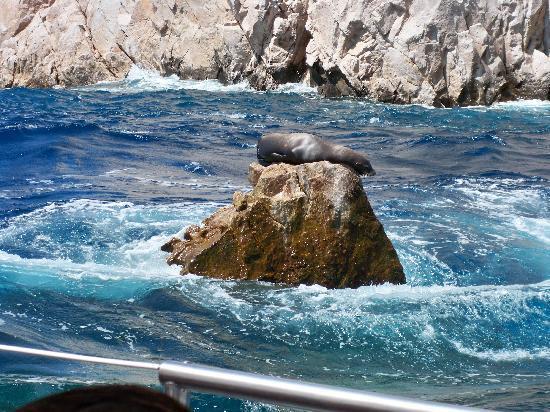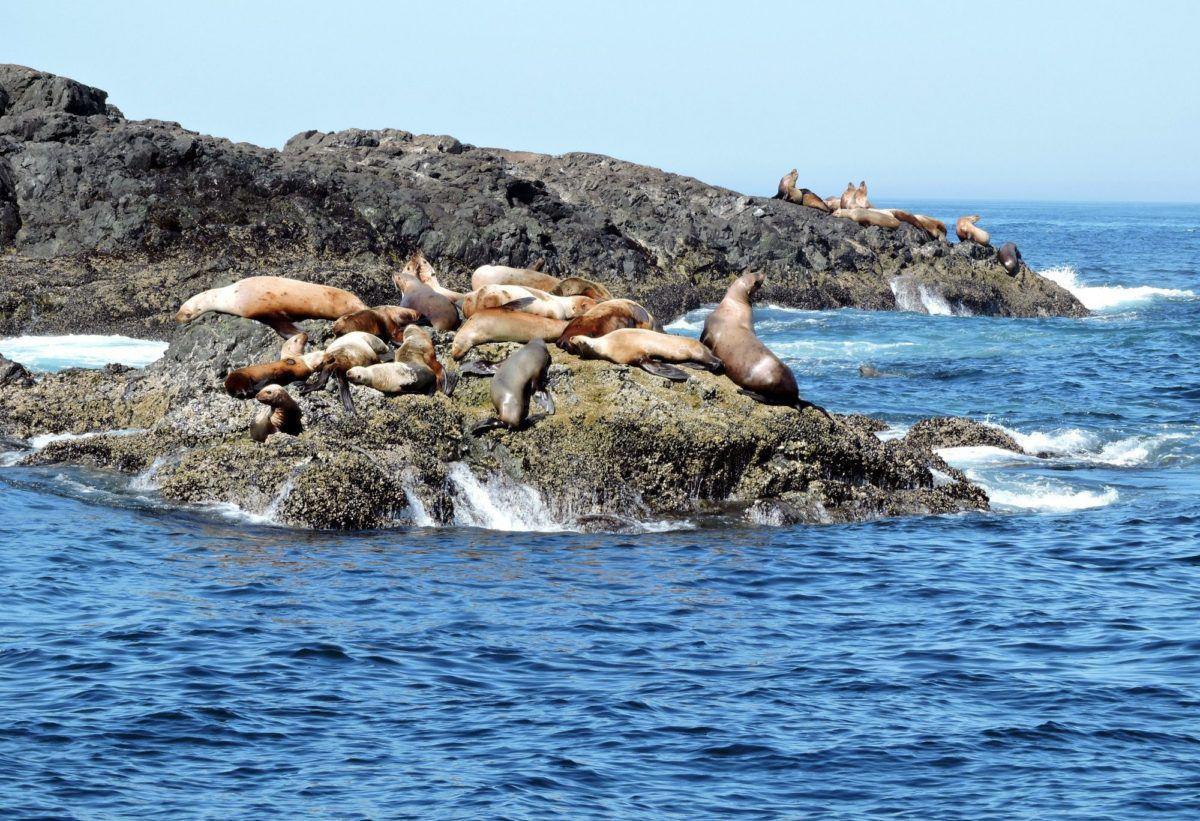The first image is the image on the left, the second image is the image on the right. Considering the images on both sides, is "There are no more than 8 seals in the image on the left." valid? Answer yes or no. Yes. 